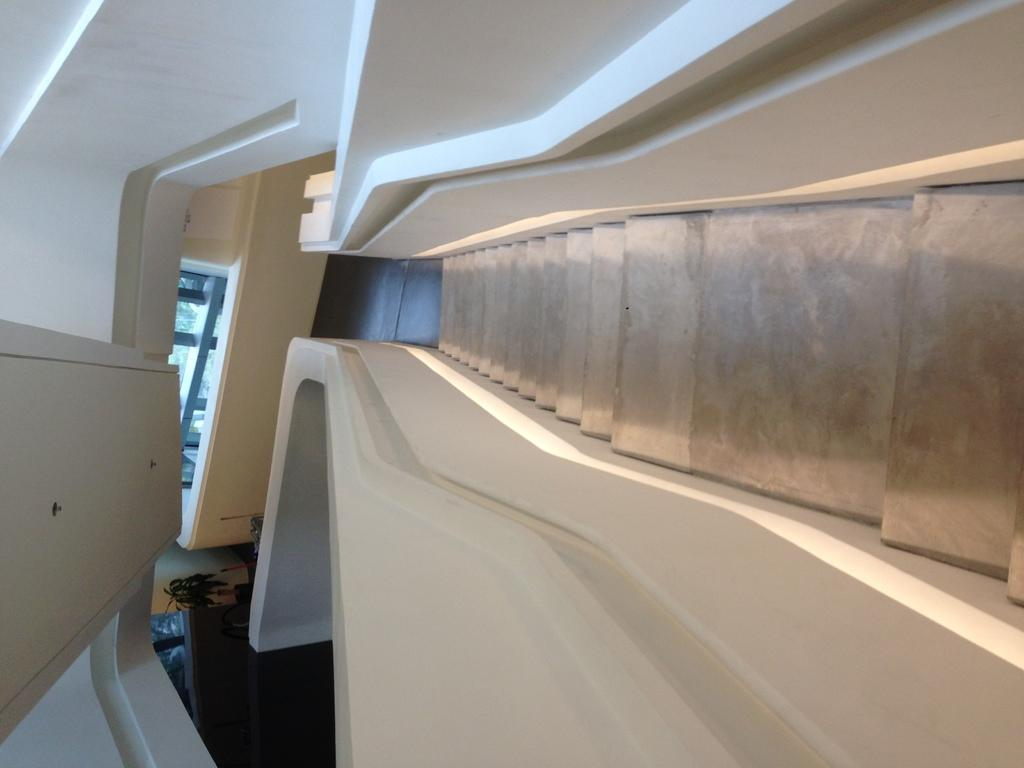What can be seen at the front of the image? There are steps in the front of the image with light. What is present on both sides of the steps? There are walls on both sides of the steps. What is visible in the background of the image? There is a glass window in the background of the image. What is above the steps in the image? There is a ceiling visible in the image. What year is depicted in the image? The provided facts do not mention any specific year, so it cannot be determined from the image. Are there any police officers present in the image? There is no mention of police officers in the provided facts, so it cannot be determined from the image. 